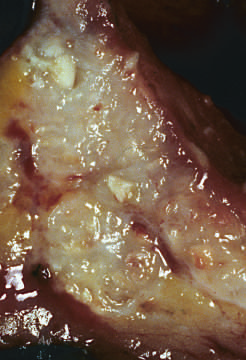what are present within the colon wall?
Answer the question using a single word or phrase. Areas of chalky necrosis 